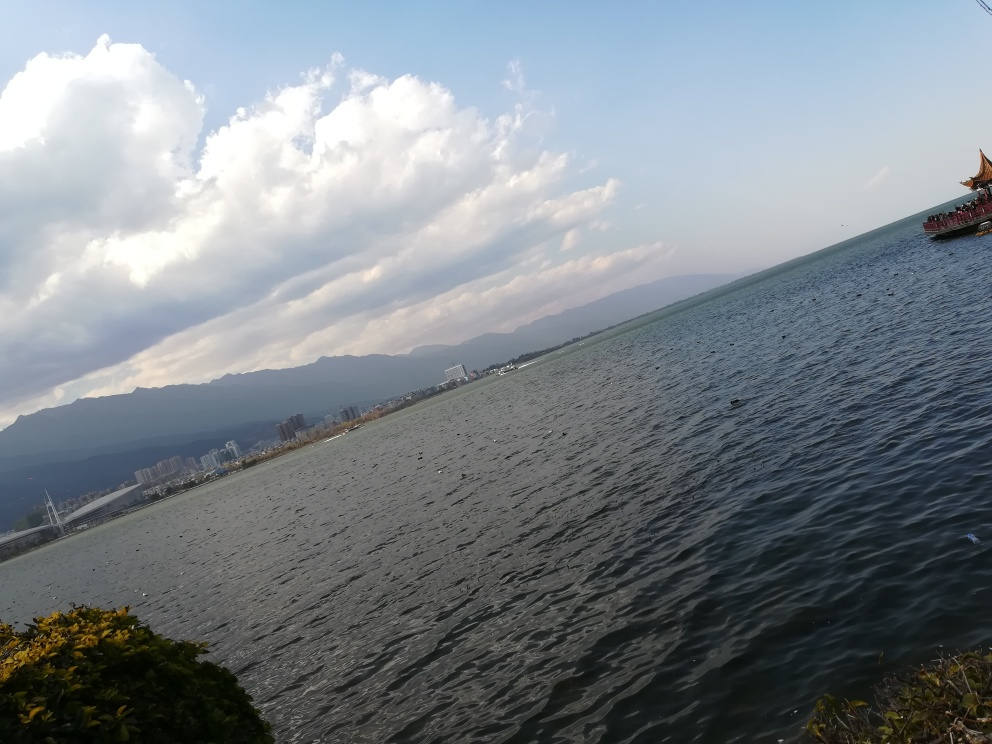What can you tell me about the climate in this region? While it's difficult to make precise claims about the climate from a single image, the presence of lush greenery suggests a temperate or subtropical climate with sufficient rainfall. The mountain range also implies potential variability in local weather patterns. 